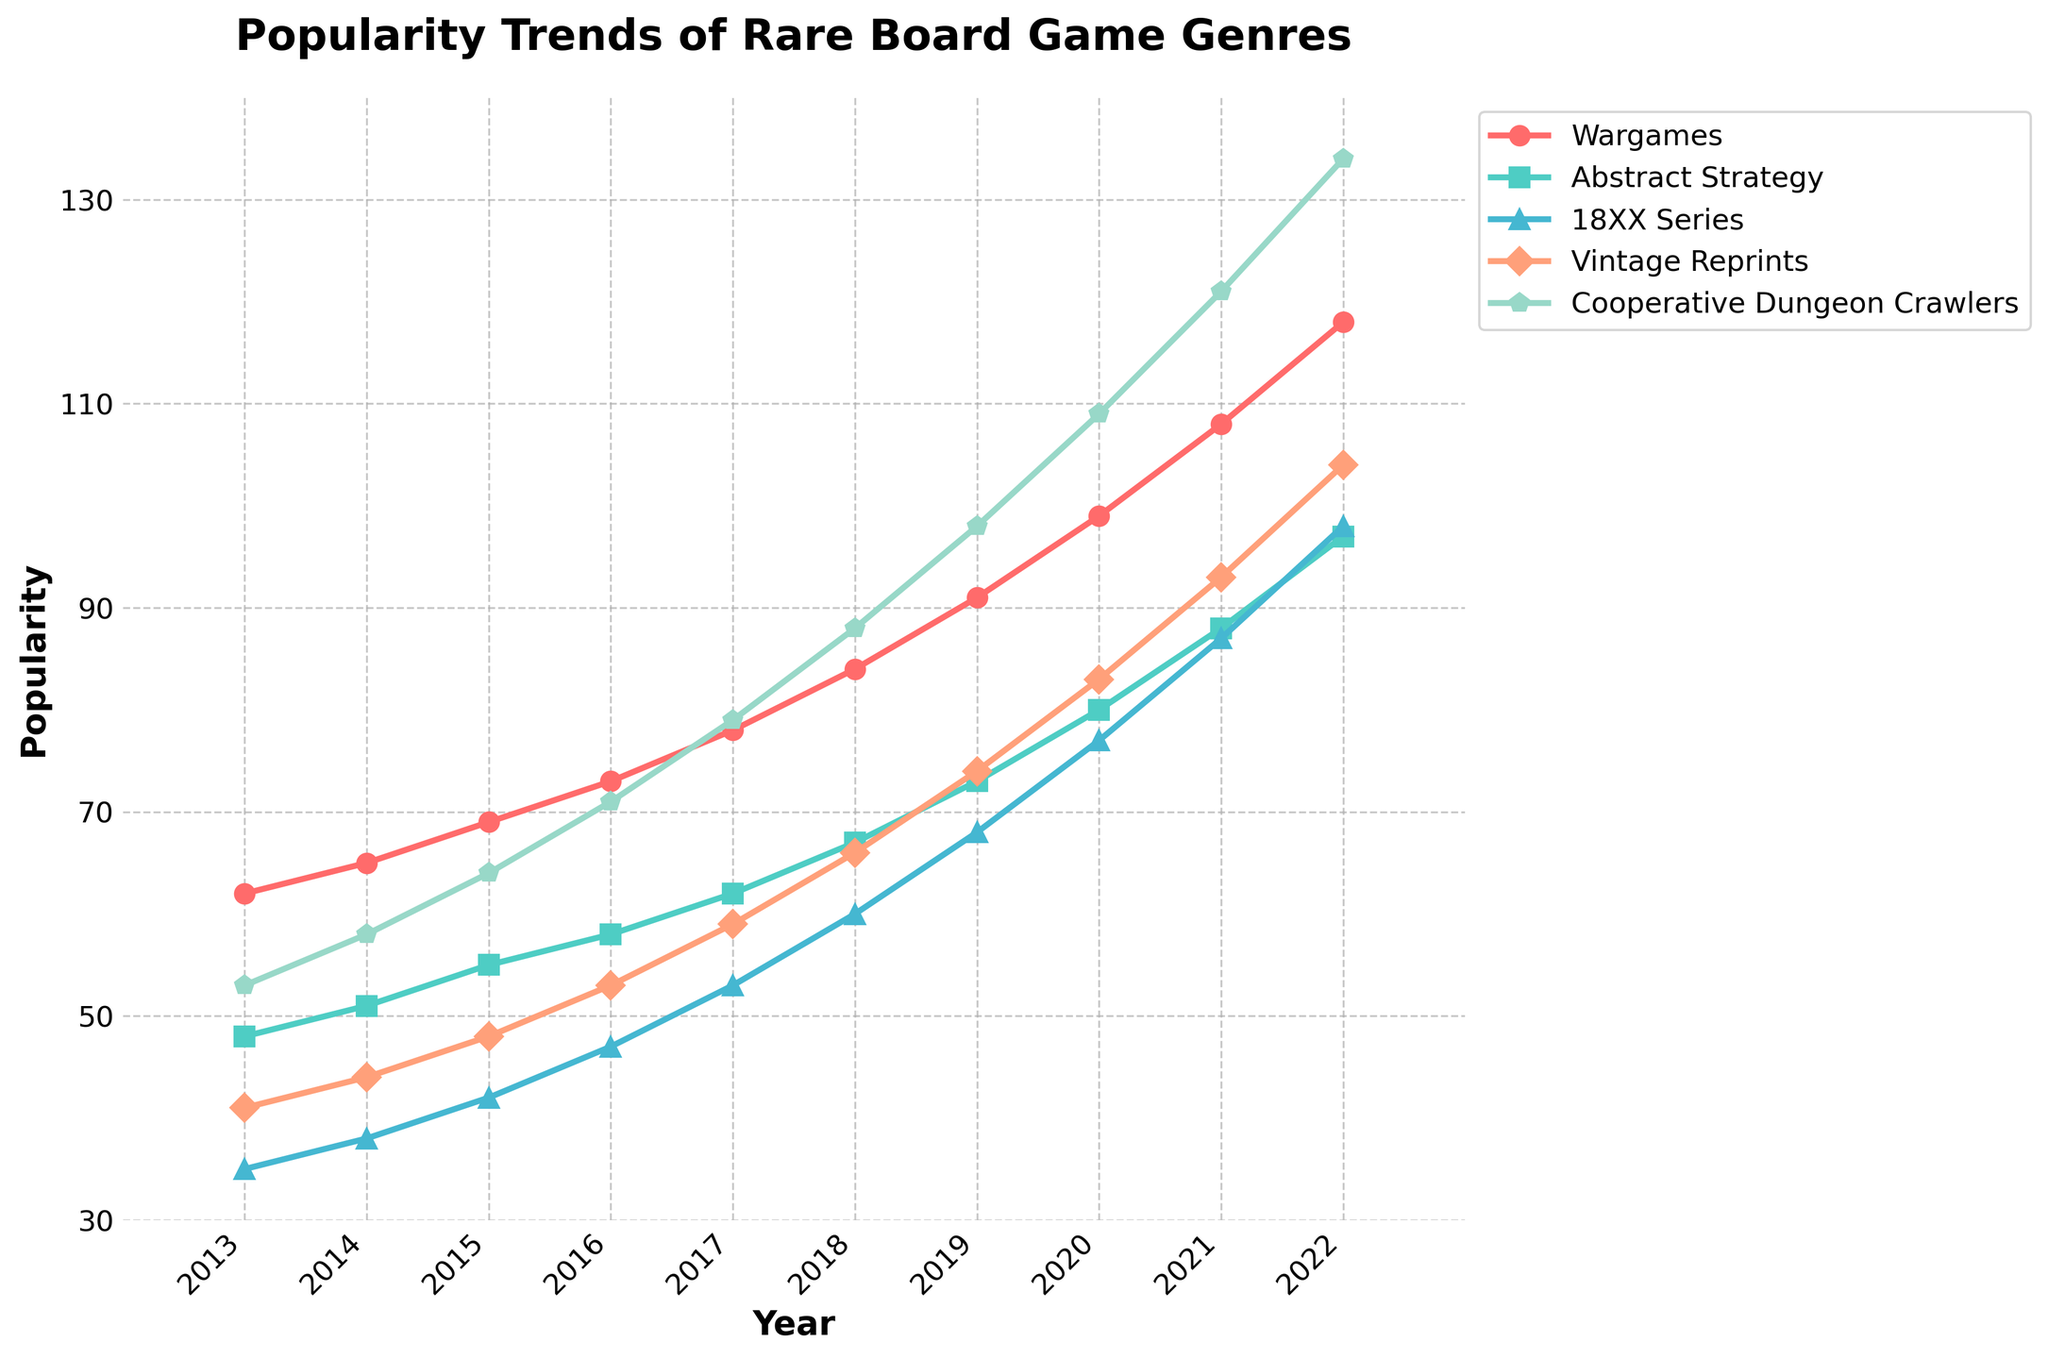What's the trend of "Wargames" genre over the past decade? The trend can be observed by looking at the "Wargames" line on the chart, which is consistently increasing from 2013 to 2022, starting at 62 and ending at 118.
Answer: Increasing Which genre has the highest popularity in 2022? To determine this, we check the values for each genre in 2022. "Cooperative Dungeon Crawlers" has the highest value at 134.
Answer: Cooperative Dungeon Crawlers Did any genre experience a decline in popularity at any point over the decade? By examining the lines for all genres, we see that all lines are upward trending with no dips, indicating continuous growth.
Answer: No In which year did "18XX Series" surpass 70 in popularity? The "18XX Series" line can be analyzed to see that it crosses 70 between 2018 and 2019. Specifically, it reaches 68 in 2019 and surpasses 70 in 2020.
Answer: 2020 What is the average popularity of "Abstract Strategy" from 2013 to 2015? Sum the popularity values of "Abstract Strategy" from 2013 to 2015 (48 + 51 + 55) and divide by the number of years (3). (48 + 51 + 55) / 3 = 154 / 3 = 51.33.
Answer: 51.33 Which genre has the steepest growth rate between 2013 and 2022? To determine this, compare the difference in popularity from 2013 to 2022 for all genres. The increases are: "Wargames" (118-62 = 56), "Abstract Strategy" (97-48 = 49), "18XX Series" (98-35 = 63), "Vintage Reprints" (104-41 = 63), "Cooperative Dungeon Crawlers" (134-53 = 81). "Cooperative Dungeon Crawlers" has the highest increase.
Answer: Cooperative Dungeon Crawlers How does the growth of "Vintage Reprints" compare to "18XX Series" over the decade? Calculate the difference in popularity for each genre from 2013 to 2022. For "Vintage Reprints," it's 104 - 41 = 63. For "18XX Series," it's 98 - 35 = 63. Both genres increase by 63 points.
Answer: Equal What is the visual color used to represent the "Wargames" genre in the plot? By looking at the plot, we identify the color associated with the "Wargames" line. It is represented in red.
Answer: Red Which two genres are the closest in popularity in 2017? Check the values for 2017 and identify the two closest in popularity. "Abstract Strategy" (62) and "Vintage Reprints" (59) have the smallest difference (3 points).
Answer: Abstract Strategy and Vintage Reprints What are the popularity values of "Cooperative Dungeon Crawlers" in 2016 and 2019, and how much did it increase during this period? Find the popularity values for "Cooperative Dungeon Crawlers" in 2016 (71) and 2019 (98) and calculate the difference: 98 - 71 = 27.
Answer: 27 